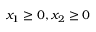Convert formula to latex. <formula><loc_0><loc_0><loc_500><loc_500>x _ { 1 } \geq 0 , x _ { 2 } \geq 0</formula> 